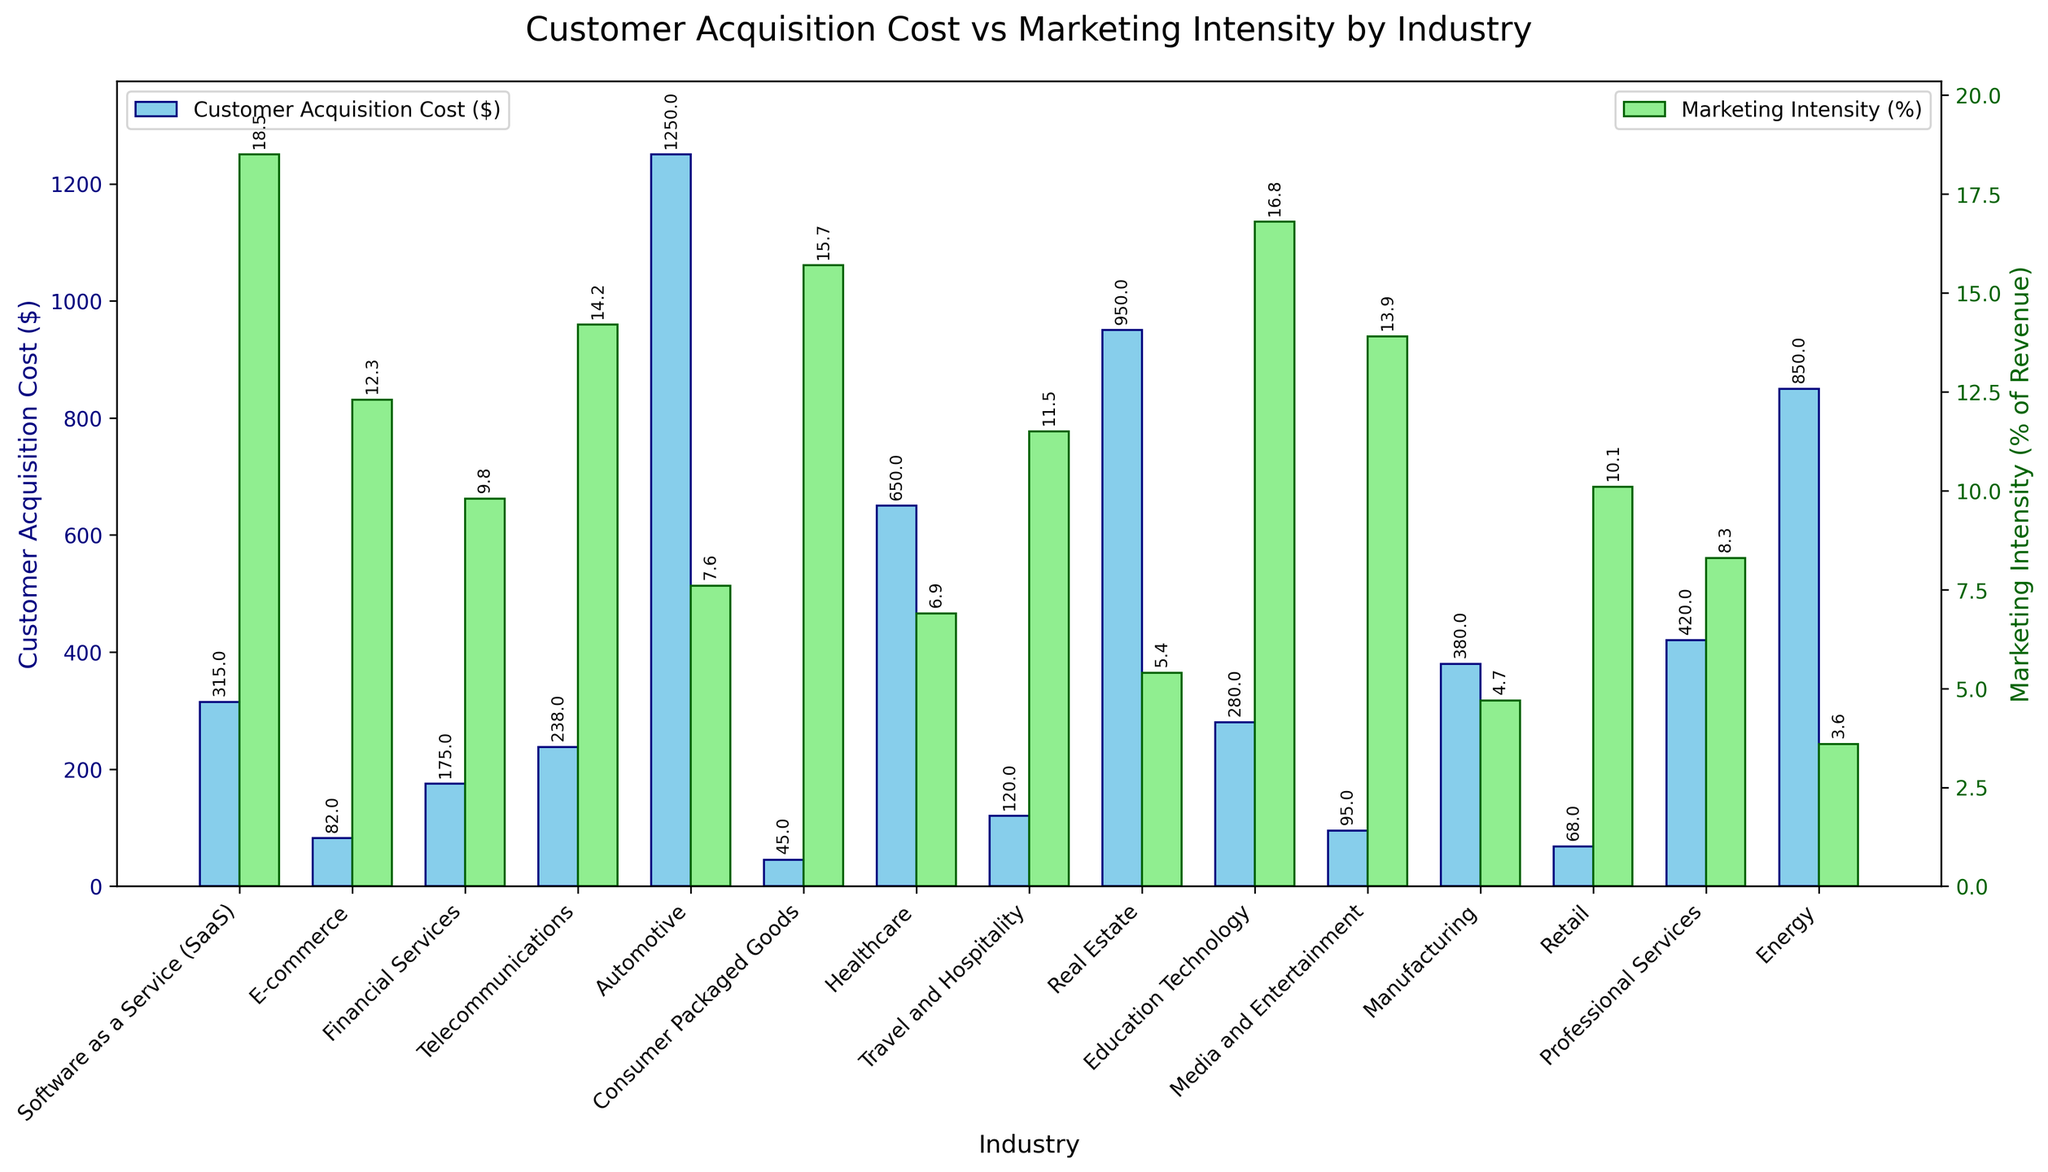What's the industry with the highest customer acquisition cost (CAC)? By examining the height of the bars representing CAC, the Automotive industry appears to have the tallest bar, indicating the highest CAC.
Answer: Automotive Which industry has the lowest marketing intensity as a percentage of revenue? By looking at the bars representing marketing intensity, the Energy industry has the shortest bar, indicating the lowest marketing intensity.
Answer: Energy Which two industries have the closest customer acquisition costs? By comparing the height of the bars for all the industries, the Manufacturing and Professional Services industries have customer acquisition costs that are close in height.
Answer: Manufacturing and Professional Services Which industry spends more on marketing intensity but less on customer acquisition cost: Healthcare or Retail? By comparing the height of the bars, Retail has a higher green bar representing marketing intensity and a lower blue bar representing customer acquisition cost compared to Healthcare.
Answer: Retail What's the difference in customer acquisition cost between the SaaS and Consumer Packaged Goods industries? The CAC for SaaS is $315 and for Consumer Packaged Goods is $45. The difference is calculated as 315 - 45 = 270.
Answer: 270 Which industry has a higher customer acquisition cost: Telecommunications or E-commerce? By comparing the height of the blue CAC bars, Telecommunications has a taller bar than E-commerce, indicating a higher customer acquisition cost.
Answer: Telecommunications What is the sum of customer acquisition costs for Travel and Hospitality, and Real Estate industries? The CAC for Travel and Hospitality is $120 and for Real Estate is $950. The sum is 120 + 950 = 1070.
Answer: 1070 Which industry shows a greater discrepancy between customer acquisition cost and marketing intensity: Energy or Media and Entertainment? By comparing the height differences between the blue (CAC) and green (marketing intensity) bars for both industries, the Energy industry shows a much larger discrepancy.
Answer: Energy What is the average marketing intensity percentage for the E-commerce and Education Technology industries? The marketing intensity for E-commerce is 12.3% and for Education Technology is 16.8%. The average is calculated as (12.3 + 16.8) / 2 = 14.55%.
Answer: 14.55 Which industry has a lower customer acquisition cost but higher marketing intensity compared to Financial Services: manufactured or Media and Entertainment? By comparing the bar heights for CAC, both Manufacturing and Media and Entertainment have lower CAC bars. However, Media and Entertainment also has a higher marketing intensity bar compared to Financial Services.
Answer: Media and Entertainment 